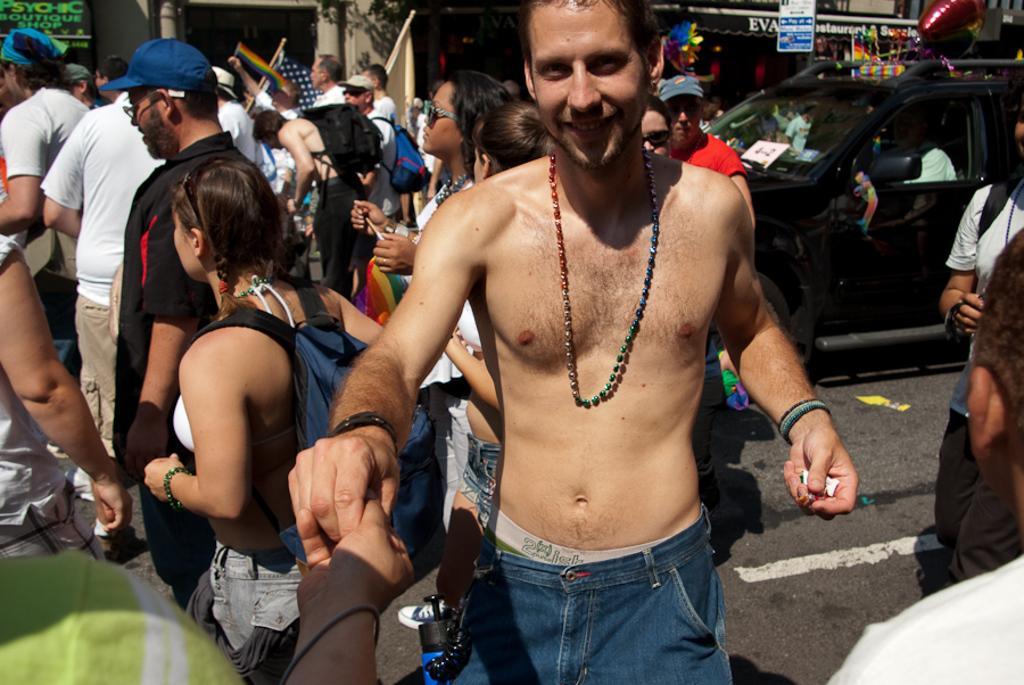What is happening on the road in the image? There are people on the road in the image, and a car is moving on the road. Can you describe the expression of one of the people in the image? Yes, a man is smiling in the image. What type of law does the boy practice in the image? There is no boy or lawyer present in the image; it only features people on the road and a man who is smiling. 